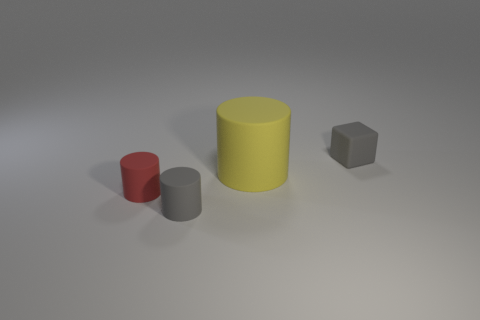How big is the gray matte thing in front of the big yellow matte thing?
Provide a succinct answer. Small. What material is the yellow cylinder?
Keep it short and to the point. Rubber. Does the gray matte object that is on the left side of the cube have the same shape as the yellow object?
Make the answer very short. Yes. There is a cylinder that is the same color as the rubber cube; what is its size?
Give a very brief answer. Small. Is there a blue metallic block of the same size as the gray cube?
Your answer should be very brief. No. Is there a tiny matte thing to the left of the small rubber cylinder that is behind the small gray rubber object that is to the left of the gray block?
Provide a succinct answer. No. There is a tiny cube; does it have the same color as the small cylinder behind the gray matte cylinder?
Offer a terse response. No. What is the small object that is to the right of the gray object on the left side of the tiny matte thing that is to the right of the large matte object made of?
Your response must be concise. Rubber. What shape is the gray matte thing in front of the tiny gray block?
Provide a short and direct response. Cylinder. There is a yellow thing that is the same material as the small red object; what size is it?
Your answer should be very brief. Large. 